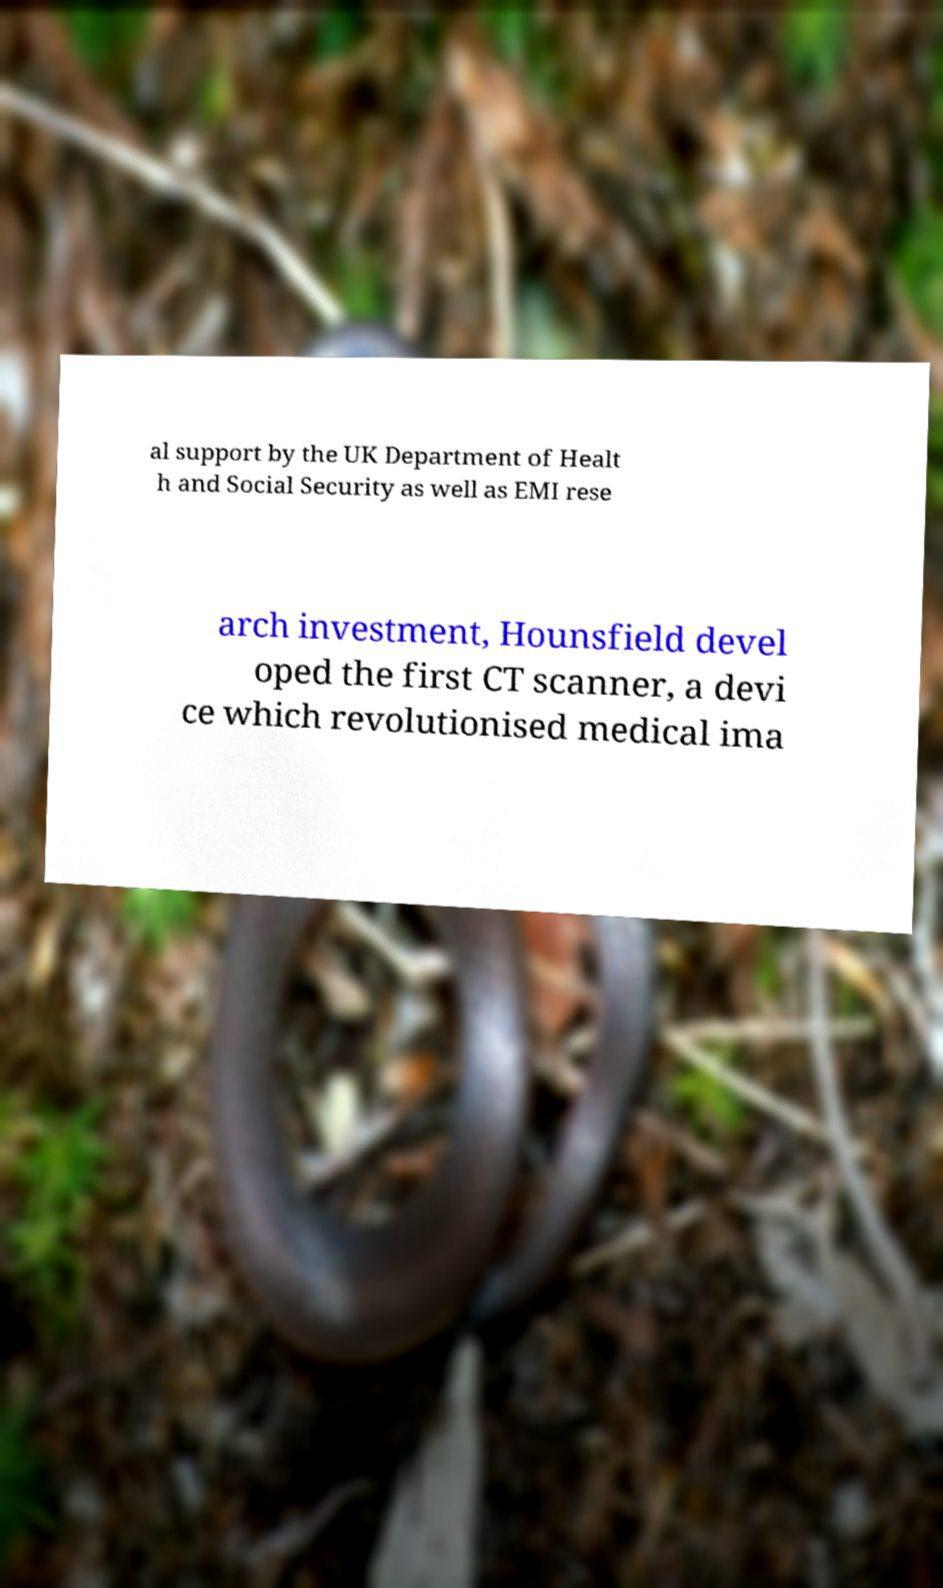I need the written content from this picture converted into text. Can you do that? al support by the UK Department of Healt h and Social Security as well as EMI rese arch investment, Hounsfield devel oped the first CT scanner, a devi ce which revolutionised medical ima 